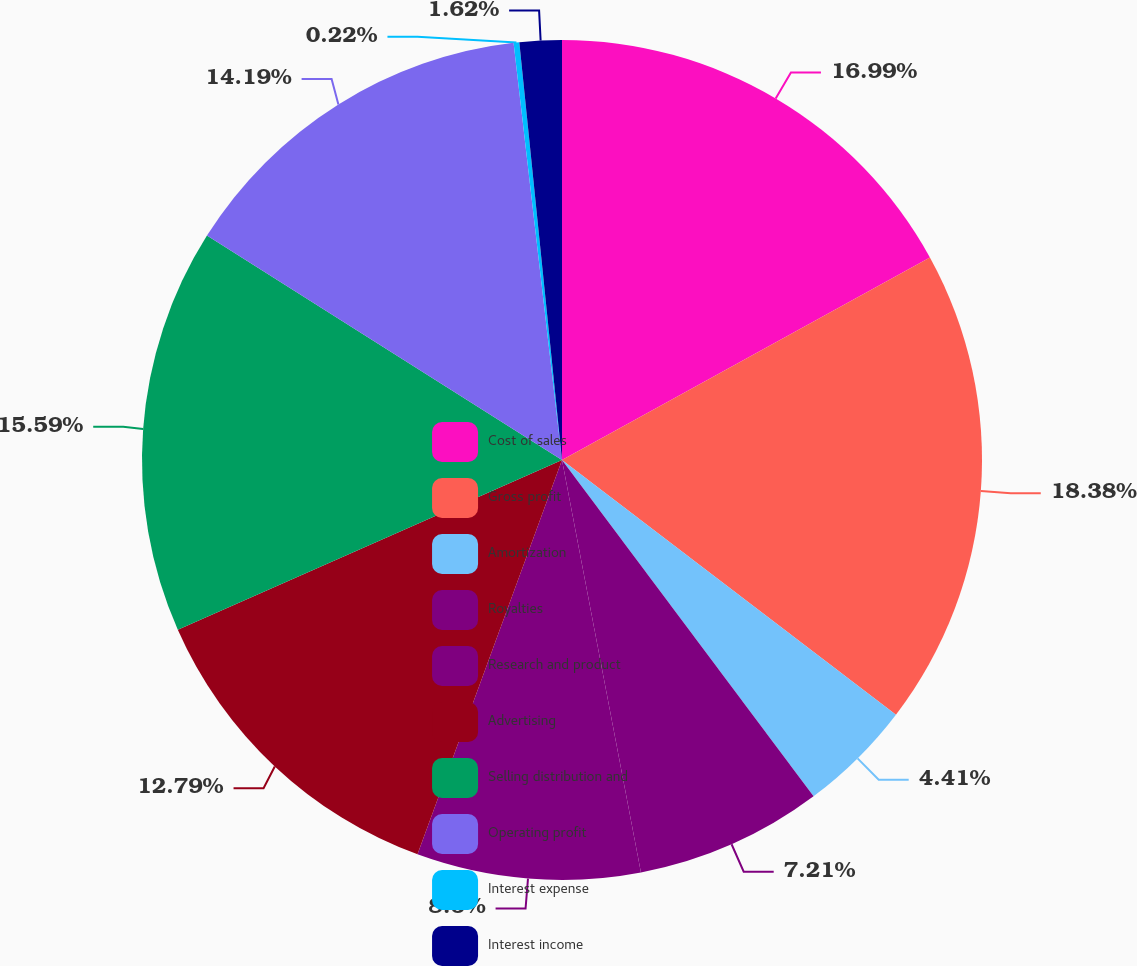Convert chart to OTSL. <chart><loc_0><loc_0><loc_500><loc_500><pie_chart><fcel>Cost of sales<fcel>Gross profit<fcel>Amortization<fcel>Royalties<fcel>Research and product<fcel>Advertising<fcel>Selling distribution and<fcel>Operating profit<fcel>Interest expense<fcel>Interest income<nl><fcel>16.99%<fcel>18.38%<fcel>4.41%<fcel>7.21%<fcel>8.6%<fcel>12.79%<fcel>15.59%<fcel>14.19%<fcel>0.22%<fcel>1.62%<nl></chart> 